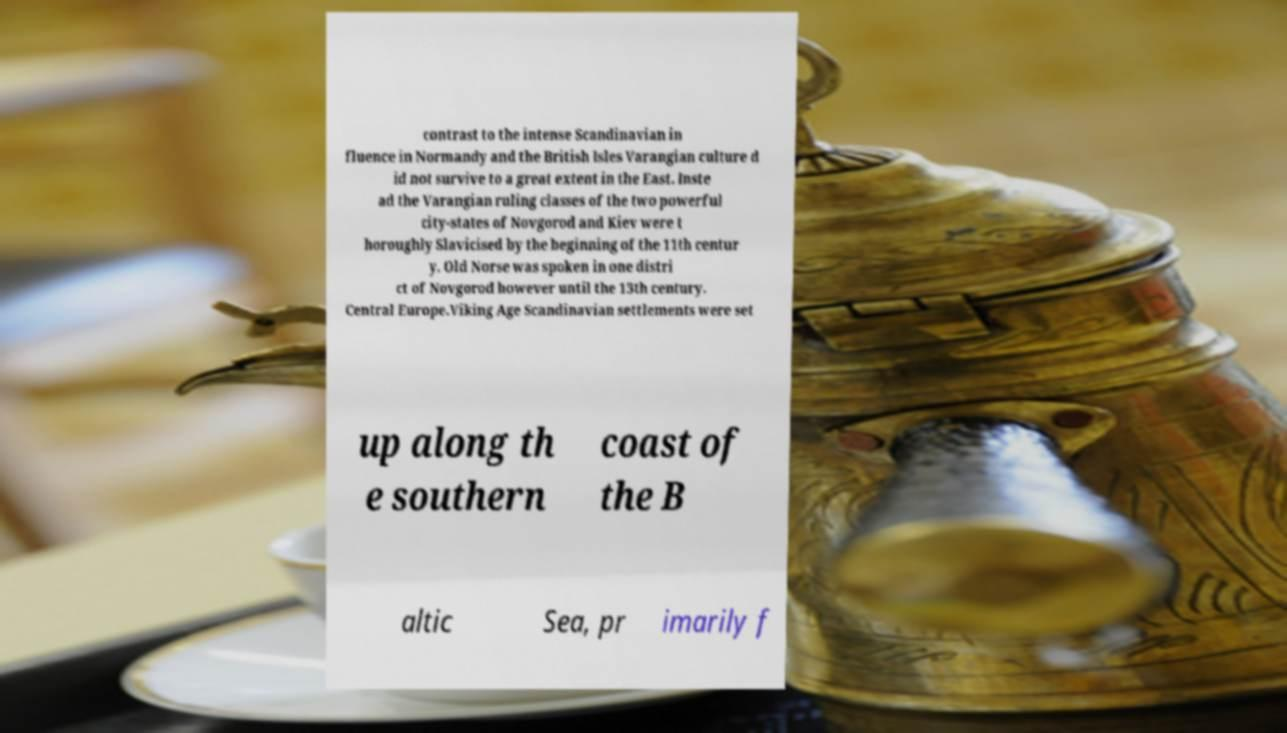There's text embedded in this image that I need extracted. Can you transcribe it verbatim? contrast to the intense Scandinavian in fluence in Normandy and the British Isles Varangian culture d id not survive to a great extent in the East. Inste ad the Varangian ruling classes of the two powerful city-states of Novgorod and Kiev were t horoughly Slavicised by the beginning of the 11th centur y. Old Norse was spoken in one distri ct of Novgorod however until the 13th century. Central Europe.Viking Age Scandinavian settlements were set up along th e southern coast of the B altic Sea, pr imarily f 